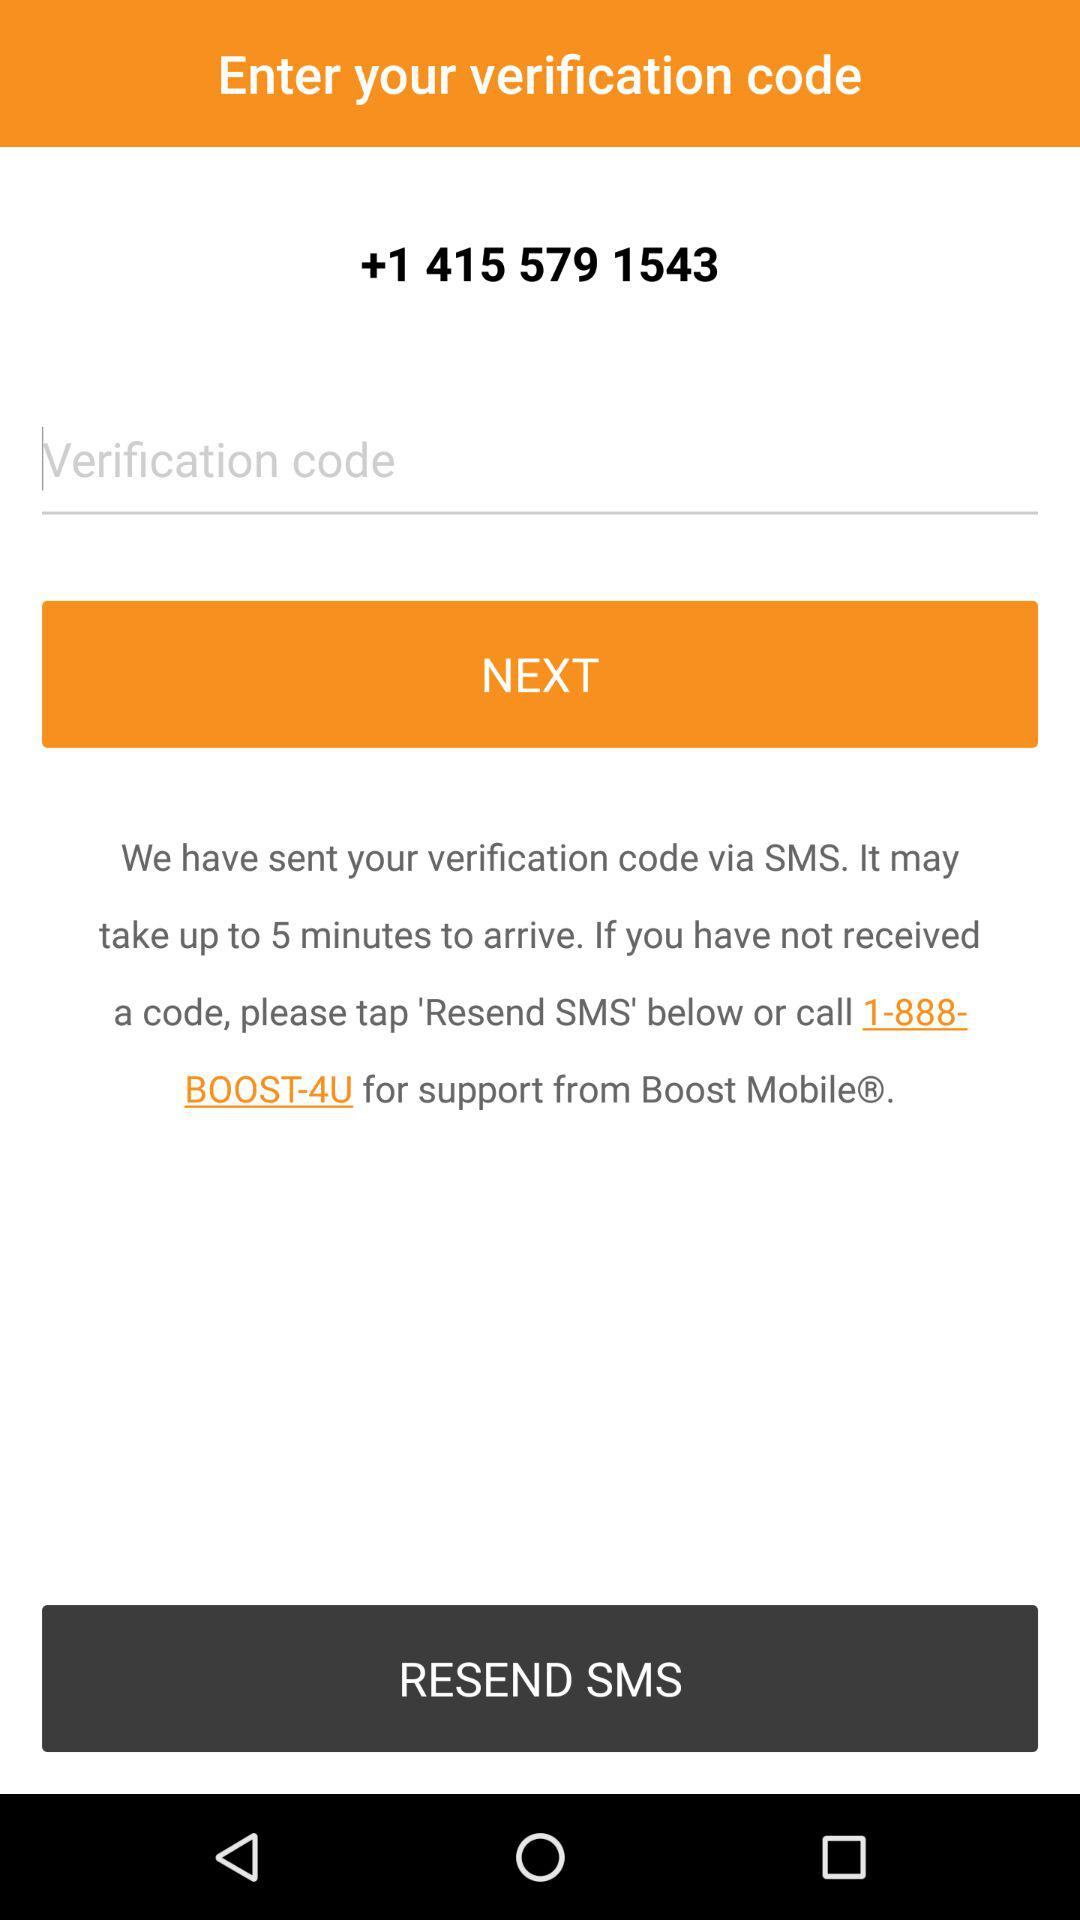At what number do we have to call, if we didn't receive the code? You have to call 1-888-BOOST-4U. 